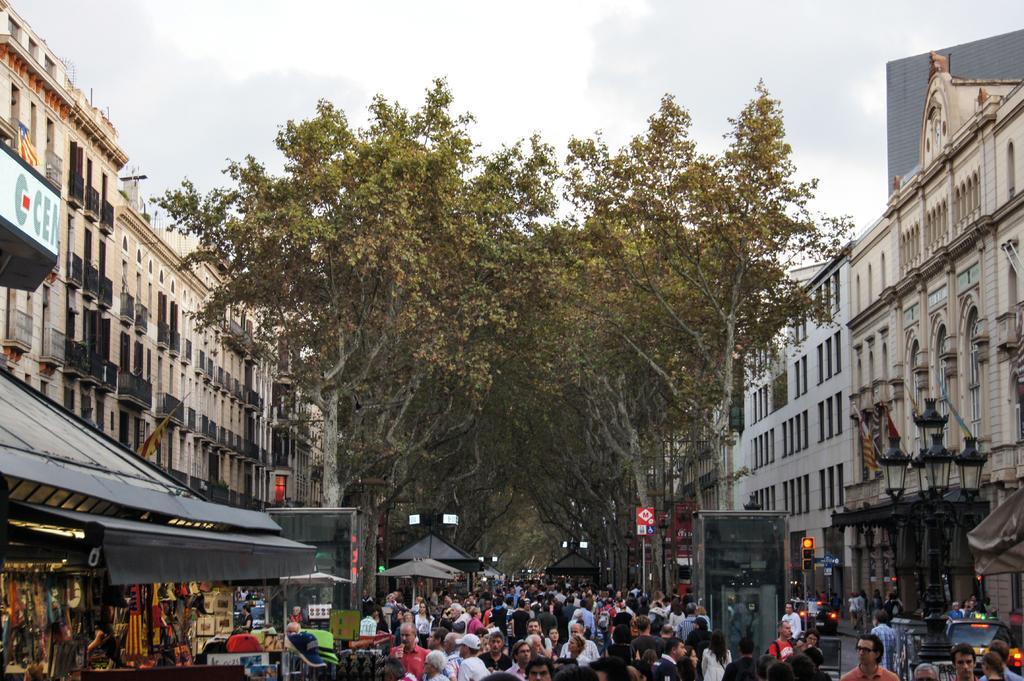Describe this image in one or two sentences. In this image there is a road at the bottom. On the road there are so many people. On the right side there are stores and shops at the bottom. In the background there are trees. There are buildings on either side of the road. On the right side there is a traffic signal light on the footpath. This image is taken in the street. 